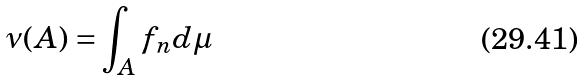<formula> <loc_0><loc_0><loc_500><loc_500>\nu ( A ) = \int _ { A } f _ { n } d \mu</formula> 